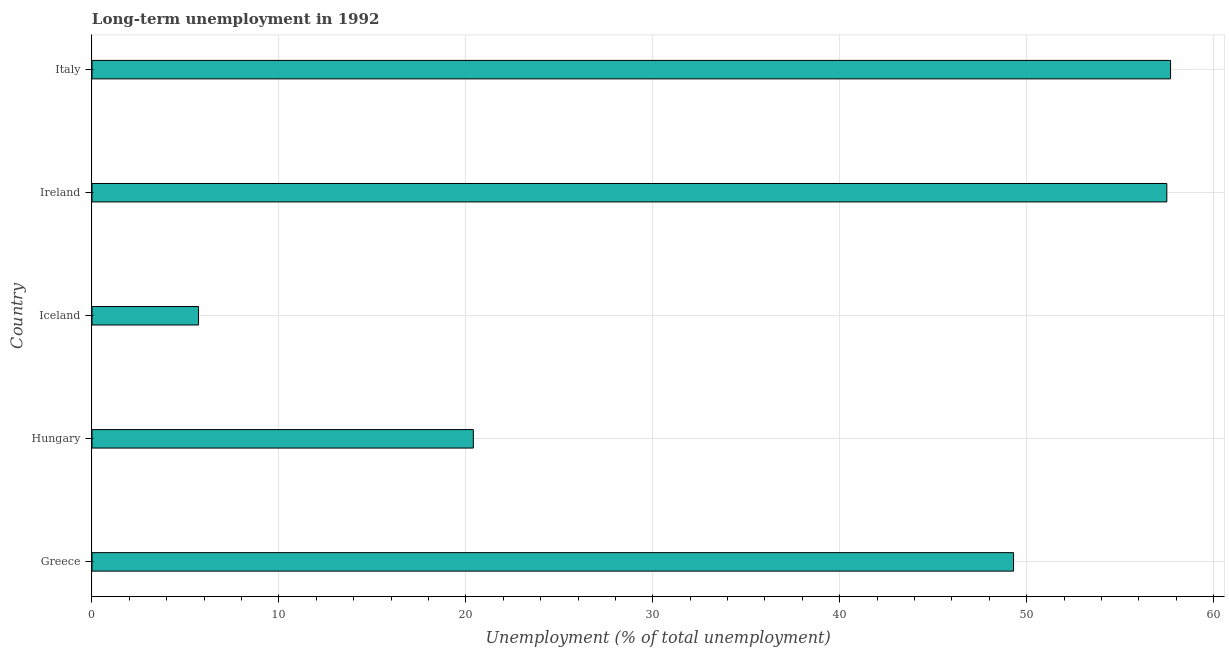Does the graph contain any zero values?
Make the answer very short. No. Does the graph contain grids?
Provide a short and direct response. Yes. What is the title of the graph?
Your answer should be very brief. Long-term unemployment in 1992. What is the label or title of the X-axis?
Provide a short and direct response. Unemployment (% of total unemployment). What is the label or title of the Y-axis?
Your response must be concise. Country. What is the long-term unemployment in Hungary?
Offer a very short reply. 20.4. Across all countries, what is the maximum long-term unemployment?
Make the answer very short. 57.7. Across all countries, what is the minimum long-term unemployment?
Offer a very short reply. 5.7. What is the sum of the long-term unemployment?
Your response must be concise. 190.6. What is the average long-term unemployment per country?
Your response must be concise. 38.12. What is the median long-term unemployment?
Ensure brevity in your answer.  49.3. What is the ratio of the long-term unemployment in Hungary to that in Ireland?
Provide a succinct answer. 0.35. Is the long-term unemployment in Greece less than that in Ireland?
Your answer should be compact. Yes. Is the difference between the long-term unemployment in Greece and Ireland greater than the difference between any two countries?
Keep it short and to the point. No. How many bars are there?
Make the answer very short. 5. Are all the bars in the graph horizontal?
Provide a succinct answer. Yes. Are the values on the major ticks of X-axis written in scientific E-notation?
Your answer should be compact. No. What is the Unemployment (% of total unemployment) in Greece?
Ensure brevity in your answer.  49.3. What is the Unemployment (% of total unemployment) in Hungary?
Offer a terse response. 20.4. What is the Unemployment (% of total unemployment) in Iceland?
Give a very brief answer. 5.7. What is the Unemployment (% of total unemployment) in Ireland?
Offer a very short reply. 57.5. What is the Unemployment (% of total unemployment) of Italy?
Your answer should be very brief. 57.7. What is the difference between the Unemployment (% of total unemployment) in Greece and Hungary?
Your answer should be very brief. 28.9. What is the difference between the Unemployment (% of total unemployment) in Greece and Iceland?
Keep it short and to the point. 43.6. What is the difference between the Unemployment (% of total unemployment) in Greece and Ireland?
Your answer should be compact. -8.2. What is the difference between the Unemployment (% of total unemployment) in Hungary and Iceland?
Your response must be concise. 14.7. What is the difference between the Unemployment (% of total unemployment) in Hungary and Ireland?
Offer a terse response. -37.1. What is the difference between the Unemployment (% of total unemployment) in Hungary and Italy?
Keep it short and to the point. -37.3. What is the difference between the Unemployment (% of total unemployment) in Iceland and Ireland?
Your answer should be very brief. -51.8. What is the difference between the Unemployment (% of total unemployment) in Iceland and Italy?
Give a very brief answer. -52. What is the ratio of the Unemployment (% of total unemployment) in Greece to that in Hungary?
Offer a terse response. 2.42. What is the ratio of the Unemployment (% of total unemployment) in Greece to that in Iceland?
Give a very brief answer. 8.65. What is the ratio of the Unemployment (% of total unemployment) in Greece to that in Ireland?
Your response must be concise. 0.86. What is the ratio of the Unemployment (% of total unemployment) in Greece to that in Italy?
Ensure brevity in your answer.  0.85. What is the ratio of the Unemployment (% of total unemployment) in Hungary to that in Iceland?
Provide a short and direct response. 3.58. What is the ratio of the Unemployment (% of total unemployment) in Hungary to that in Ireland?
Ensure brevity in your answer.  0.35. What is the ratio of the Unemployment (% of total unemployment) in Hungary to that in Italy?
Offer a terse response. 0.35. What is the ratio of the Unemployment (% of total unemployment) in Iceland to that in Ireland?
Offer a very short reply. 0.1. What is the ratio of the Unemployment (% of total unemployment) in Iceland to that in Italy?
Give a very brief answer. 0.1. 